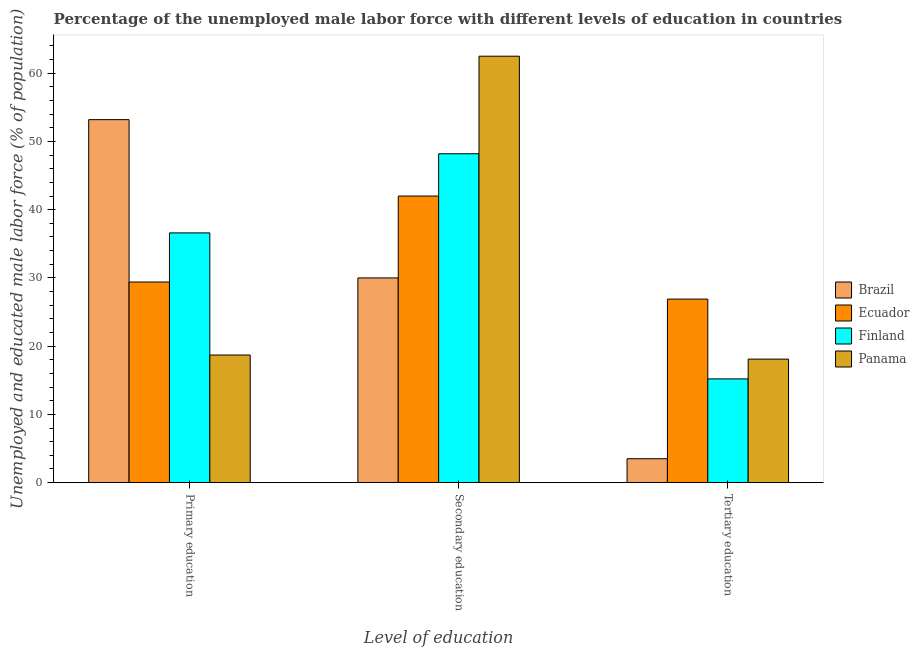How many different coloured bars are there?
Your response must be concise. 4. Are the number of bars on each tick of the X-axis equal?
Offer a very short reply. Yes. How many bars are there on the 2nd tick from the left?
Provide a short and direct response. 4. What is the label of the 2nd group of bars from the left?
Provide a short and direct response. Secondary education. Across all countries, what is the maximum percentage of male labor force who received tertiary education?
Your answer should be very brief. 26.9. Across all countries, what is the minimum percentage of male labor force who received primary education?
Your answer should be compact. 18.7. In which country was the percentage of male labor force who received secondary education maximum?
Make the answer very short. Panama. What is the total percentage of male labor force who received secondary education in the graph?
Offer a terse response. 182.7. What is the difference between the percentage of male labor force who received tertiary education in Brazil and that in Panama?
Keep it short and to the point. -14.6. What is the difference between the percentage of male labor force who received primary education in Ecuador and the percentage of male labor force who received tertiary education in Panama?
Your answer should be compact. 11.3. What is the average percentage of male labor force who received primary education per country?
Ensure brevity in your answer.  34.47. What is the difference between the percentage of male labor force who received primary education and percentage of male labor force who received tertiary education in Brazil?
Offer a very short reply. 49.7. What is the ratio of the percentage of male labor force who received secondary education in Brazil to that in Finland?
Offer a terse response. 0.62. What is the difference between the highest and the second highest percentage of male labor force who received secondary education?
Make the answer very short. 14.3. What is the difference between the highest and the lowest percentage of male labor force who received secondary education?
Provide a short and direct response. 32.5. Is the sum of the percentage of male labor force who received tertiary education in Panama and Brazil greater than the maximum percentage of male labor force who received secondary education across all countries?
Keep it short and to the point. No. What does the 3rd bar from the left in Primary education represents?
Offer a terse response. Finland. What does the 4th bar from the right in Secondary education represents?
Keep it short and to the point. Brazil. Is it the case that in every country, the sum of the percentage of male labor force who received primary education and percentage of male labor force who received secondary education is greater than the percentage of male labor force who received tertiary education?
Provide a short and direct response. Yes. Are all the bars in the graph horizontal?
Keep it short and to the point. No. Are the values on the major ticks of Y-axis written in scientific E-notation?
Offer a very short reply. No. Does the graph contain any zero values?
Your answer should be very brief. No. How many legend labels are there?
Provide a succinct answer. 4. How are the legend labels stacked?
Keep it short and to the point. Vertical. What is the title of the graph?
Keep it short and to the point. Percentage of the unemployed male labor force with different levels of education in countries. What is the label or title of the X-axis?
Offer a terse response. Level of education. What is the label or title of the Y-axis?
Your answer should be compact. Unemployed and educated male labor force (% of population). What is the Unemployed and educated male labor force (% of population) in Brazil in Primary education?
Your answer should be very brief. 53.2. What is the Unemployed and educated male labor force (% of population) in Ecuador in Primary education?
Your answer should be compact. 29.4. What is the Unemployed and educated male labor force (% of population) in Finland in Primary education?
Your answer should be compact. 36.6. What is the Unemployed and educated male labor force (% of population) in Panama in Primary education?
Ensure brevity in your answer.  18.7. What is the Unemployed and educated male labor force (% of population) in Ecuador in Secondary education?
Provide a succinct answer. 42. What is the Unemployed and educated male labor force (% of population) in Finland in Secondary education?
Offer a very short reply. 48.2. What is the Unemployed and educated male labor force (% of population) of Panama in Secondary education?
Provide a succinct answer. 62.5. What is the Unemployed and educated male labor force (% of population) in Ecuador in Tertiary education?
Give a very brief answer. 26.9. What is the Unemployed and educated male labor force (% of population) of Finland in Tertiary education?
Provide a succinct answer. 15.2. What is the Unemployed and educated male labor force (% of population) of Panama in Tertiary education?
Make the answer very short. 18.1. Across all Level of education, what is the maximum Unemployed and educated male labor force (% of population) in Brazil?
Ensure brevity in your answer.  53.2. Across all Level of education, what is the maximum Unemployed and educated male labor force (% of population) of Finland?
Your response must be concise. 48.2. Across all Level of education, what is the maximum Unemployed and educated male labor force (% of population) in Panama?
Provide a succinct answer. 62.5. Across all Level of education, what is the minimum Unemployed and educated male labor force (% of population) in Ecuador?
Give a very brief answer. 26.9. Across all Level of education, what is the minimum Unemployed and educated male labor force (% of population) of Finland?
Your answer should be compact. 15.2. Across all Level of education, what is the minimum Unemployed and educated male labor force (% of population) of Panama?
Make the answer very short. 18.1. What is the total Unemployed and educated male labor force (% of population) in Brazil in the graph?
Offer a very short reply. 86.7. What is the total Unemployed and educated male labor force (% of population) in Ecuador in the graph?
Your answer should be compact. 98.3. What is the total Unemployed and educated male labor force (% of population) in Finland in the graph?
Offer a terse response. 100. What is the total Unemployed and educated male labor force (% of population) in Panama in the graph?
Offer a very short reply. 99.3. What is the difference between the Unemployed and educated male labor force (% of population) in Brazil in Primary education and that in Secondary education?
Provide a succinct answer. 23.2. What is the difference between the Unemployed and educated male labor force (% of population) in Ecuador in Primary education and that in Secondary education?
Provide a short and direct response. -12.6. What is the difference between the Unemployed and educated male labor force (% of population) in Panama in Primary education and that in Secondary education?
Offer a very short reply. -43.8. What is the difference between the Unemployed and educated male labor force (% of population) of Brazil in Primary education and that in Tertiary education?
Give a very brief answer. 49.7. What is the difference between the Unemployed and educated male labor force (% of population) in Ecuador in Primary education and that in Tertiary education?
Ensure brevity in your answer.  2.5. What is the difference between the Unemployed and educated male labor force (% of population) of Finland in Primary education and that in Tertiary education?
Offer a terse response. 21.4. What is the difference between the Unemployed and educated male labor force (% of population) in Finland in Secondary education and that in Tertiary education?
Your response must be concise. 33. What is the difference between the Unemployed and educated male labor force (% of population) in Panama in Secondary education and that in Tertiary education?
Provide a short and direct response. 44.4. What is the difference between the Unemployed and educated male labor force (% of population) of Brazil in Primary education and the Unemployed and educated male labor force (% of population) of Ecuador in Secondary education?
Your answer should be compact. 11.2. What is the difference between the Unemployed and educated male labor force (% of population) of Brazil in Primary education and the Unemployed and educated male labor force (% of population) of Finland in Secondary education?
Ensure brevity in your answer.  5. What is the difference between the Unemployed and educated male labor force (% of population) in Brazil in Primary education and the Unemployed and educated male labor force (% of population) in Panama in Secondary education?
Your response must be concise. -9.3. What is the difference between the Unemployed and educated male labor force (% of population) of Ecuador in Primary education and the Unemployed and educated male labor force (% of population) of Finland in Secondary education?
Provide a short and direct response. -18.8. What is the difference between the Unemployed and educated male labor force (% of population) of Ecuador in Primary education and the Unemployed and educated male labor force (% of population) of Panama in Secondary education?
Offer a terse response. -33.1. What is the difference between the Unemployed and educated male labor force (% of population) of Finland in Primary education and the Unemployed and educated male labor force (% of population) of Panama in Secondary education?
Provide a succinct answer. -25.9. What is the difference between the Unemployed and educated male labor force (% of population) of Brazil in Primary education and the Unemployed and educated male labor force (% of population) of Ecuador in Tertiary education?
Provide a succinct answer. 26.3. What is the difference between the Unemployed and educated male labor force (% of population) in Brazil in Primary education and the Unemployed and educated male labor force (% of population) in Panama in Tertiary education?
Provide a short and direct response. 35.1. What is the difference between the Unemployed and educated male labor force (% of population) of Ecuador in Primary education and the Unemployed and educated male labor force (% of population) of Finland in Tertiary education?
Offer a very short reply. 14.2. What is the difference between the Unemployed and educated male labor force (% of population) in Ecuador in Primary education and the Unemployed and educated male labor force (% of population) in Panama in Tertiary education?
Your response must be concise. 11.3. What is the difference between the Unemployed and educated male labor force (% of population) in Brazil in Secondary education and the Unemployed and educated male labor force (% of population) in Ecuador in Tertiary education?
Ensure brevity in your answer.  3.1. What is the difference between the Unemployed and educated male labor force (% of population) in Brazil in Secondary education and the Unemployed and educated male labor force (% of population) in Finland in Tertiary education?
Make the answer very short. 14.8. What is the difference between the Unemployed and educated male labor force (% of population) in Ecuador in Secondary education and the Unemployed and educated male labor force (% of population) in Finland in Tertiary education?
Offer a very short reply. 26.8. What is the difference between the Unemployed and educated male labor force (% of population) of Ecuador in Secondary education and the Unemployed and educated male labor force (% of population) of Panama in Tertiary education?
Keep it short and to the point. 23.9. What is the difference between the Unemployed and educated male labor force (% of population) of Finland in Secondary education and the Unemployed and educated male labor force (% of population) of Panama in Tertiary education?
Your response must be concise. 30.1. What is the average Unemployed and educated male labor force (% of population) in Brazil per Level of education?
Keep it short and to the point. 28.9. What is the average Unemployed and educated male labor force (% of population) in Ecuador per Level of education?
Offer a very short reply. 32.77. What is the average Unemployed and educated male labor force (% of population) of Finland per Level of education?
Give a very brief answer. 33.33. What is the average Unemployed and educated male labor force (% of population) in Panama per Level of education?
Offer a very short reply. 33.1. What is the difference between the Unemployed and educated male labor force (% of population) of Brazil and Unemployed and educated male labor force (% of population) of Ecuador in Primary education?
Keep it short and to the point. 23.8. What is the difference between the Unemployed and educated male labor force (% of population) in Brazil and Unemployed and educated male labor force (% of population) in Finland in Primary education?
Keep it short and to the point. 16.6. What is the difference between the Unemployed and educated male labor force (% of population) of Brazil and Unemployed and educated male labor force (% of population) of Panama in Primary education?
Your answer should be very brief. 34.5. What is the difference between the Unemployed and educated male labor force (% of population) of Finland and Unemployed and educated male labor force (% of population) of Panama in Primary education?
Provide a succinct answer. 17.9. What is the difference between the Unemployed and educated male labor force (% of population) of Brazil and Unemployed and educated male labor force (% of population) of Ecuador in Secondary education?
Offer a terse response. -12. What is the difference between the Unemployed and educated male labor force (% of population) of Brazil and Unemployed and educated male labor force (% of population) of Finland in Secondary education?
Provide a succinct answer. -18.2. What is the difference between the Unemployed and educated male labor force (% of population) in Brazil and Unemployed and educated male labor force (% of population) in Panama in Secondary education?
Your answer should be very brief. -32.5. What is the difference between the Unemployed and educated male labor force (% of population) of Ecuador and Unemployed and educated male labor force (% of population) of Panama in Secondary education?
Make the answer very short. -20.5. What is the difference between the Unemployed and educated male labor force (% of population) of Finland and Unemployed and educated male labor force (% of population) of Panama in Secondary education?
Give a very brief answer. -14.3. What is the difference between the Unemployed and educated male labor force (% of population) in Brazil and Unemployed and educated male labor force (% of population) in Ecuador in Tertiary education?
Ensure brevity in your answer.  -23.4. What is the difference between the Unemployed and educated male labor force (% of population) of Brazil and Unemployed and educated male labor force (% of population) of Finland in Tertiary education?
Provide a succinct answer. -11.7. What is the difference between the Unemployed and educated male labor force (% of population) in Brazil and Unemployed and educated male labor force (% of population) in Panama in Tertiary education?
Your answer should be compact. -14.6. What is the difference between the Unemployed and educated male labor force (% of population) of Ecuador and Unemployed and educated male labor force (% of population) of Finland in Tertiary education?
Give a very brief answer. 11.7. What is the difference between the Unemployed and educated male labor force (% of population) of Ecuador and Unemployed and educated male labor force (% of population) of Panama in Tertiary education?
Provide a short and direct response. 8.8. What is the difference between the Unemployed and educated male labor force (% of population) of Finland and Unemployed and educated male labor force (% of population) of Panama in Tertiary education?
Keep it short and to the point. -2.9. What is the ratio of the Unemployed and educated male labor force (% of population) in Brazil in Primary education to that in Secondary education?
Your answer should be very brief. 1.77. What is the ratio of the Unemployed and educated male labor force (% of population) of Ecuador in Primary education to that in Secondary education?
Offer a very short reply. 0.7. What is the ratio of the Unemployed and educated male labor force (% of population) in Finland in Primary education to that in Secondary education?
Ensure brevity in your answer.  0.76. What is the ratio of the Unemployed and educated male labor force (% of population) of Panama in Primary education to that in Secondary education?
Your answer should be compact. 0.3. What is the ratio of the Unemployed and educated male labor force (% of population) of Ecuador in Primary education to that in Tertiary education?
Your response must be concise. 1.09. What is the ratio of the Unemployed and educated male labor force (% of population) in Finland in Primary education to that in Tertiary education?
Offer a terse response. 2.41. What is the ratio of the Unemployed and educated male labor force (% of population) in Panama in Primary education to that in Tertiary education?
Provide a short and direct response. 1.03. What is the ratio of the Unemployed and educated male labor force (% of population) of Brazil in Secondary education to that in Tertiary education?
Your answer should be very brief. 8.57. What is the ratio of the Unemployed and educated male labor force (% of population) in Ecuador in Secondary education to that in Tertiary education?
Ensure brevity in your answer.  1.56. What is the ratio of the Unemployed and educated male labor force (% of population) in Finland in Secondary education to that in Tertiary education?
Make the answer very short. 3.17. What is the ratio of the Unemployed and educated male labor force (% of population) in Panama in Secondary education to that in Tertiary education?
Give a very brief answer. 3.45. What is the difference between the highest and the second highest Unemployed and educated male labor force (% of population) in Brazil?
Make the answer very short. 23.2. What is the difference between the highest and the second highest Unemployed and educated male labor force (% of population) of Finland?
Ensure brevity in your answer.  11.6. What is the difference between the highest and the second highest Unemployed and educated male labor force (% of population) in Panama?
Your answer should be very brief. 43.8. What is the difference between the highest and the lowest Unemployed and educated male labor force (% of population) of Brazil?
Your answer should be compact. 49.7. What is the difference between the highest and the lowest Unemployed and educated male labor force (% of population) of Ecuador?
Keep it short and to the point. 15.1. What is the difference between the highest and the lowest Unemployed and educated male labor force (% of population) of Panama?
Give a very brief answer. 44.4. 